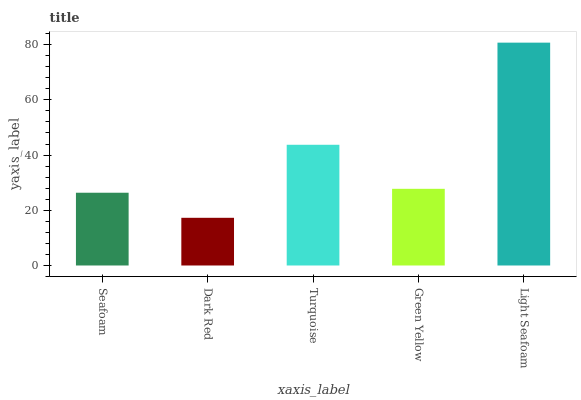Is Dark Red the minimum?
Answer yes or no. Yes. Is Light Seafoam the maximum?
Answer yes or no. Yes. Is Turquoise the minimum?
Answer yes or no. No. Is Turquoise the maximum?
Answer yes or no. No. Is Turquoise greater than Dark Red?
Answer yes or no. Yes. Is Dark Red less than Turquoise?
Answer yes or no. Yes. Is Dark Red greater than Turquoise?
Answer yes or no. No. Is Turquoise less than Dark Red?
Answer yes or no. No. Is Green Yellow the high median?
Answer yes or no. Yes. Is Green Yellow the low median?
Answer yes or no. Yes. Is Dark Red the high median?
Answer yes or no. No. Is Seafoam the low median?
Answer yes or no. No. 